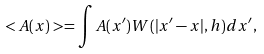<formula> <loc_0><loc_0><loc_500><loc_500>< A ( x ) > = \int A ( { x ^ { \prime } } ) W ( | { x ^ { \prime } } - { x } | , h ) d { x ^ { \prime } } ,</formula> 